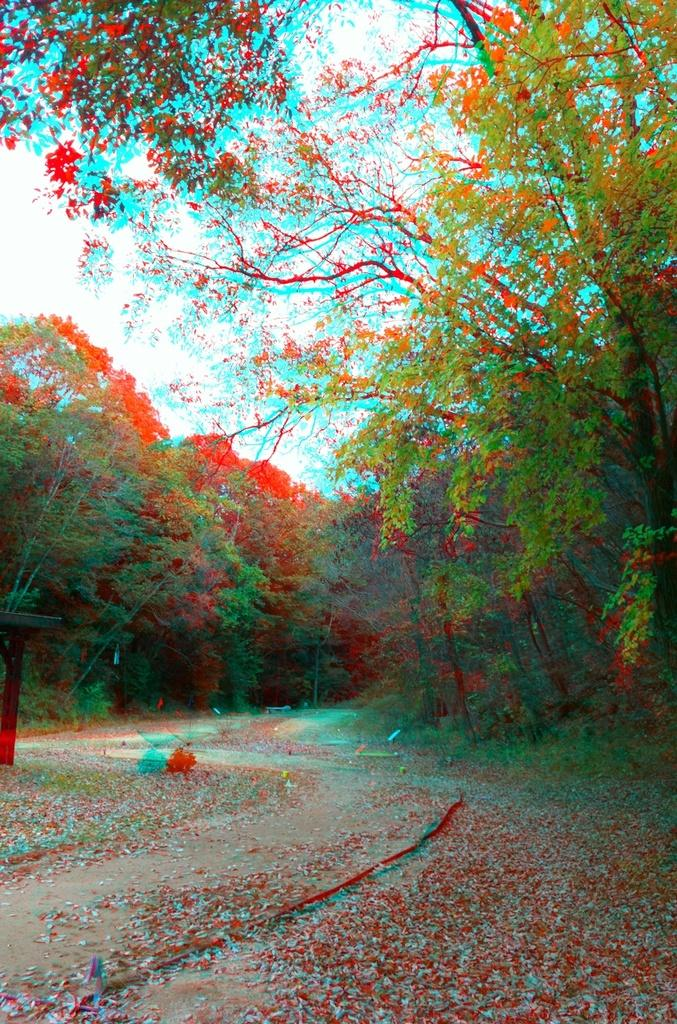What can be inferred about the image based on the first fact? The image appears to be edited, which means it may have been altered or manipulated in some way. How many trees are visible in the image? There are multiple trees in the image. What is the nature of the path in the image? The path in the image has leaves on it. What can be seen in the background of the image? The sky is visible in the background of the image. What type of operation is being performed on the table in the image? There is no table or operation present in the image. How does the image compare to a similar image of a different location? The provided facts do not allow us to make a comparison to a different image, as we only have information about this specific image. 